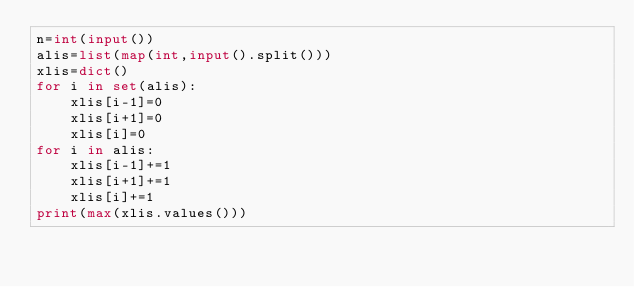Convert code to text. <code><loc_0><loc_0><loc_500><loc_500><_Python_>n=int(input())
alis=list(map(int,input().split()))
xlis=dict()
for i in set(alis):
    xlis[i-1]=0
    xlis[i+1]=0
    xlis[i]=0
for i in alis:
    xlis[i-1]+=1
    xlis[i+1]+=1
    xlis[i]+=1
print(max(xlis.values()))</code> 